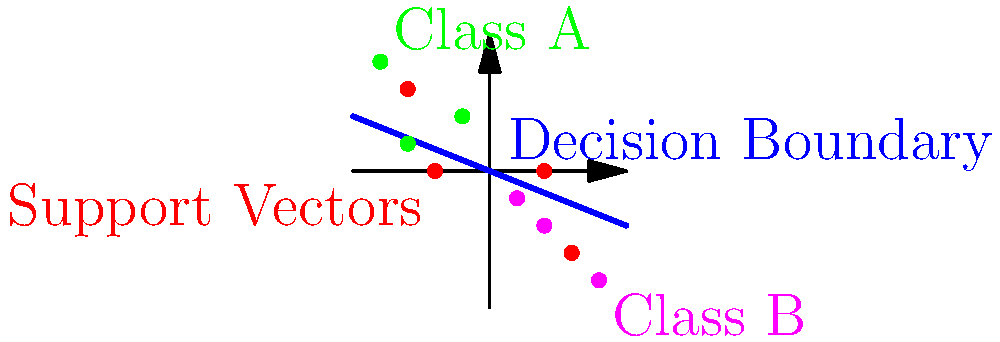In the context of Support Vector Machines (SVMs), what is the significance of the red points in the given visualization, and how do they relate to the concept of margin maximization? To understand the significance of the red points in the SVM visualization, let's break it down step-by-step:

1. SVM Classification: The graph shows a binary classification problem with two classes (green and magenta points) separated by a decision boundary (blue line).

2. Support Vectors: The red points are the support vectors. These are the data points that lie closest to the decision boundary and play a crucial role in defining it.

3. Margin: The margin is the distance between the decision boundary and the nearest data point from either class. SVM aims to maximize this margin.

4. Margin Maximization: SVM finds the optimal hyperplane (decision boundary) that maximizes the margin between the two classes. This is achieved by positioning the boundary such that it's equidistant from the closest points of each class.

5. Role of Support Vectors: The support vectors are the only points that affect the position of the decision boundary. All other points can be removed without changing the boundary.

6. Mathematical Formulation: In the SVM optimization problem, only the support vectors have non-zero Lagrange multipliers, making them the only relevant points in the dual formulation of the problem.

7. Generalization: By focusing on these boundary points (support vectors), SVM achieves better generalization, as it's less influenced by outliers or points far from the decision boundary.

8. Kernel Trick: In non-linear SVMs, support vectors are crucial for applying the kernel trick, allowing the algorithm to operate in high-dimensional spaces without explicitly computing the coordinates in that space.

The red points (support vectors) are therefore critical in defining the decision boundary and maximizing the margin, which is the core principle of SVM's ability to create an optimal separating hyperplane.
Answer: Support vectors; crucial for defining decision boundary and maximizing margin 